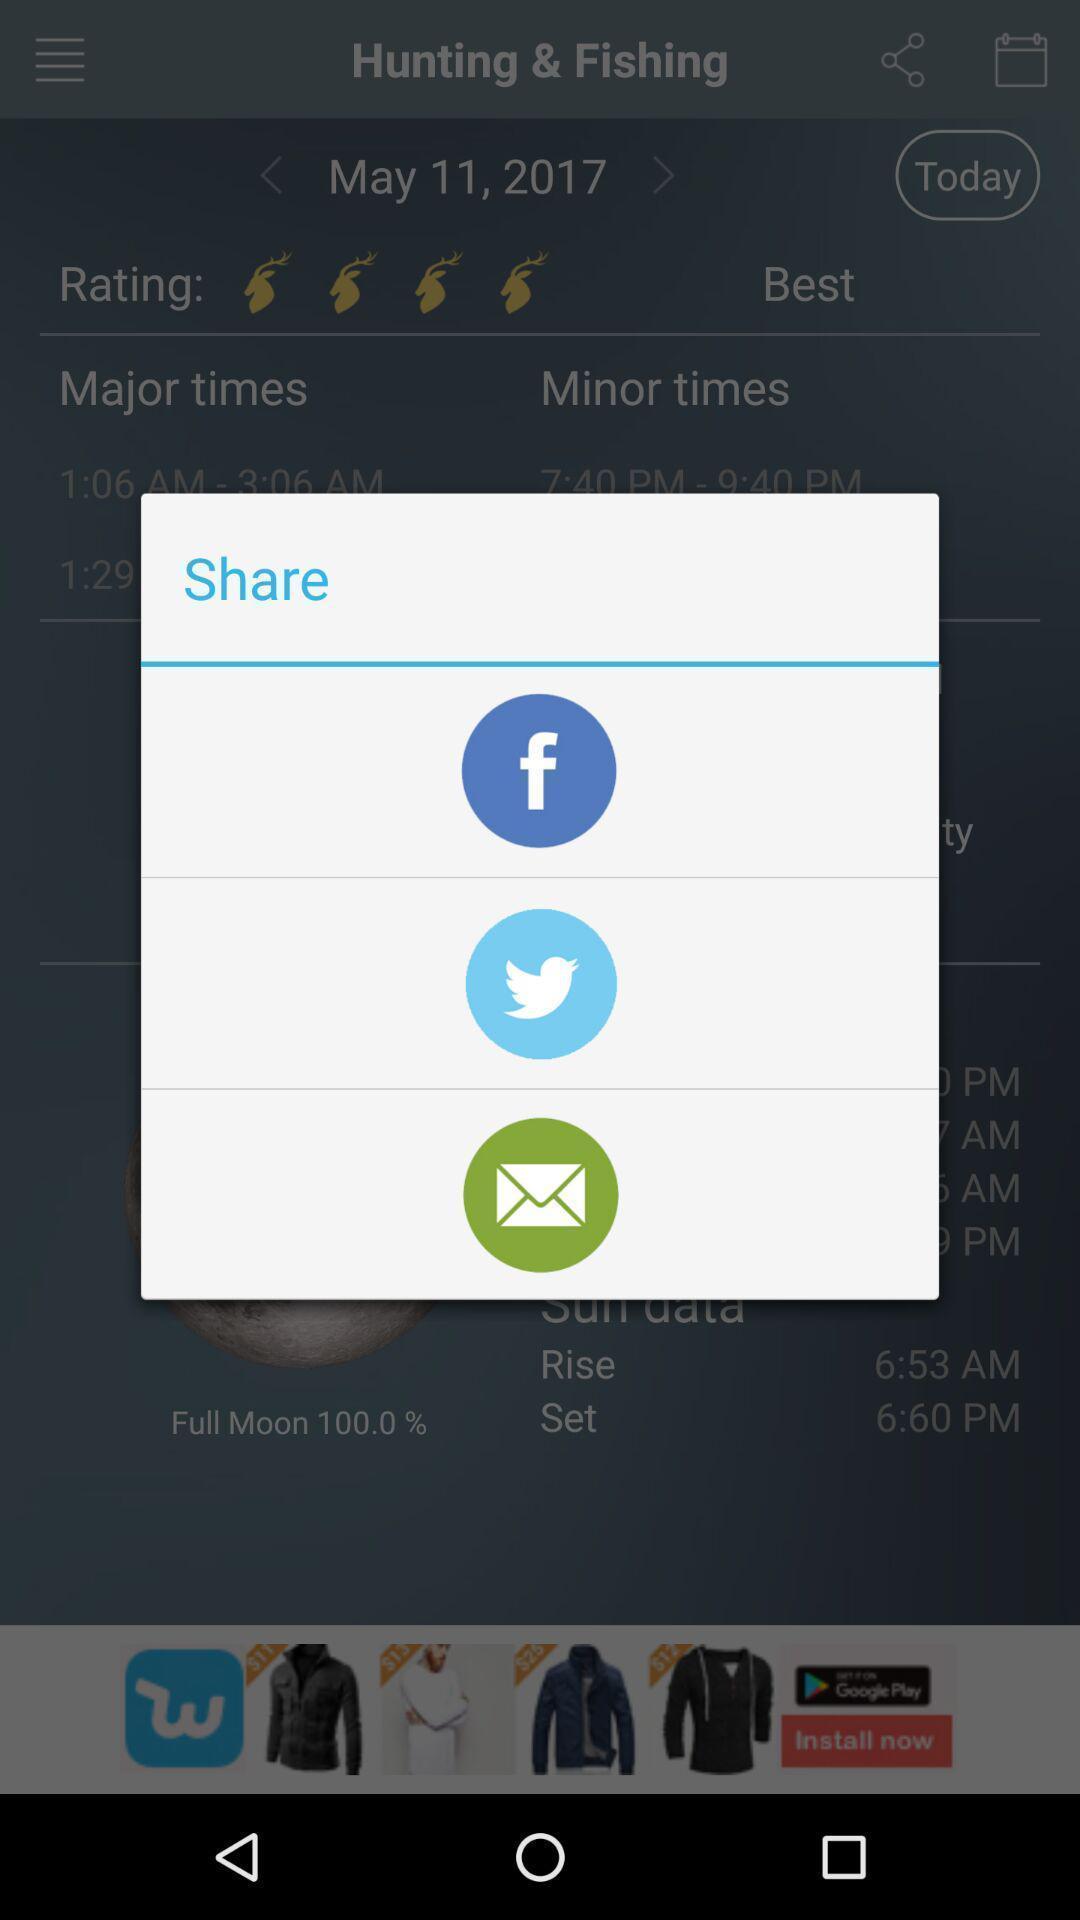Summarize the main components in this picture. Pop-up showing different sharing options. 